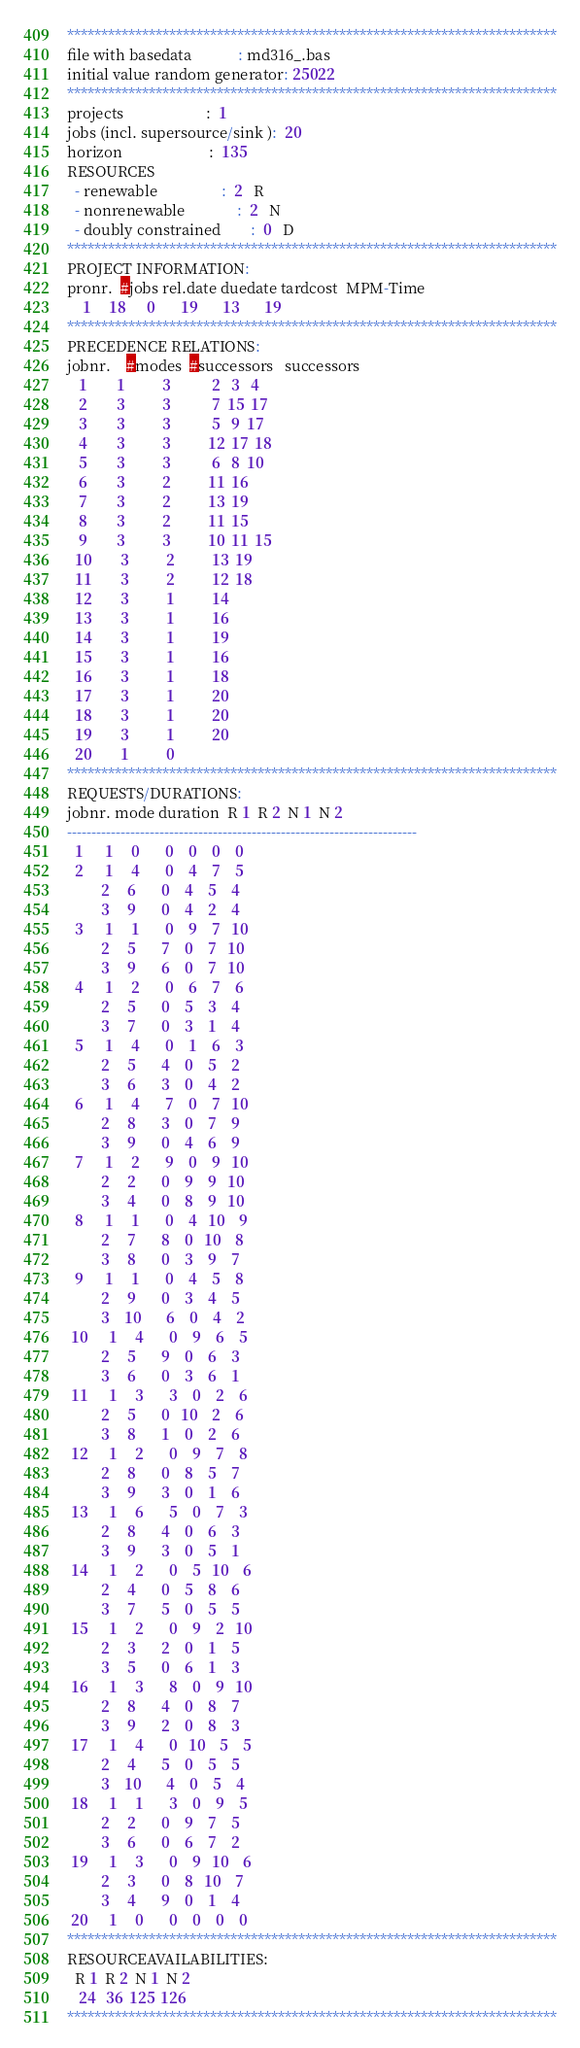Convert code to text. <code><loc_0><loc_0><loc_500><loc_500><_ObjectiveC_>************************************************************************
file with basedata            : md316_.bas
initial value random generator: 25022
************************************************************************
projects                      :  1
jobs (incl. supersource/sink ):  20
horizon                       :  135
RESOURCES
  - renewable                 :  2   R
  - nonrenewable              :  2   N
  - doubly constrained        :  0   D
************************************************************************
PROJECT INFORMATION:
pronr.  #jobs rel.date duedate tardcost  MPM-Time
    1     18      0       19       13       19
************************************************************************
PRECEDENCE RELATIONS:
jobnr.    #modes  #successors   successors
   1        1          3           2   3   4
   2        3          3           7  15  17
   3        3          3           5   9  17
   4        3          3          12  17  18
   5        3          3           6   8  10
   6        3          2          11  16
   7        3          2          13  19
   8        3          2          11  15
   9        3          3          10  11  15
  10        3          2          13  19
  11        3          2          12  18
  12        3          1          14
  13        3          1          16
  14        3          1          19
  15        3          1          16
  16        3          1          18
  17        3          1          20
  18        3          1          20
  19        3          1          20
  20        1          0        
************************************************************************
REQUESTS/DURATIONS:
jobnr. mode duration  R 1  R 2  N 1  N 2
------------------------------------------------------------------------
  1      1     0       0    0    0    0
  2      1     4       0    4    7    5
         2     6       0    4    5    4
         3     9       0    4    2    4
  3      1     1       0    9    7   10
         2     5       7    0    7   10
         3     9       6    0    7   10
  4      1     2       0    6    7    6
         2     5       0    5    3    4
         3     7       0    3    1    4
  5      1     4       0    1    6    3
         2     5       4    0    5    2
         3     6       3    0    4    2
  6      1     4       7    0    7   10
         2     8       3    0    7    9
         3     9       0    4    6    9
  7      1     2       9    0    9   10
         2     2       0    9    9   10
         3     4       0    8    9   10
  8      1     1       0    4   10    9
         2     7       8    0   10    8
         3     8       0    3    9    7
  9      1     1       0    4    5    8
         2     9       0    3    4    5
         3    10       6    0    4    2
 10      1     4       0    9    6    5
         2     5       9    0    6    3
         3     6       0    3    6    1
 11      1     3       3    0    2    6
         2     5       0   10    2    6
         3     8       1    0    2    6
 12      1     2       0    9    7    8
         2     8       0    8    5    7
         3     9       3    0    1    6
 13      1     6       5    0    7    3
         2     8       4    0    6    3
         3     9       3    0    5    1
 14      1     2       0    5   10    6
         2     4       0    5    8    6
         3     7       5    0    5    5
 15      1     2       0    9    2   10
         2     3       2    0    1    5
         3     5       0    6    1    3
 16      1     3       8    0    9   10
         2     8       4    0    8    7
         3     9       2    0    8    3
 17      1     4       0   10    5    5
         2     4       5    0    5    5
         3    10       4    0    5    4
 18      1     1       3    0    9    5
         2     2       0    9    7    5
         3     6       0    6    7    2
 19      1     3       0    9   10    6
         2     3       0    8   10    7
         3     4       9    0    1    4
 20      1     0       0    0    0    0
************************************************************************
RESOURCEAVAILABILITIES:
  R 1  R 2  N 1  N 2
   24   36  125  126
************************************************************************
</code> 